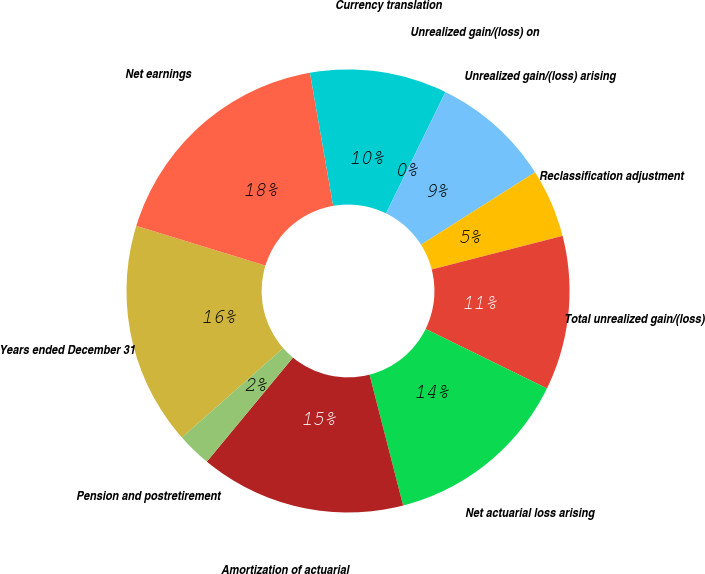Convert chart. <chart><loc_0><loc_0><loc_500><loc_500><pie_chart><fcel>Years ended December 31<fcel>Net earnings<fcel>Currency translation<fcel>Unrealized gain/(loss) on<fcel>Unrealized gain/(loss) arising<fcel>Reclassification adjustment<fcel>Total unrealized gain/(loss)<fcel>Net actuarial loss arising<fcel>Amortization of actuarial<fcel>Pension and postretirement<nl><fcel>16.25%<fcel>17.5%<fcel>10.0%<fcel>0.0%<fcel>8.75%<fcel>5.0%<fcel>11.25%<fcel>13.75%<fcel>15.0%<fcel>2.5%<nl></chart> 